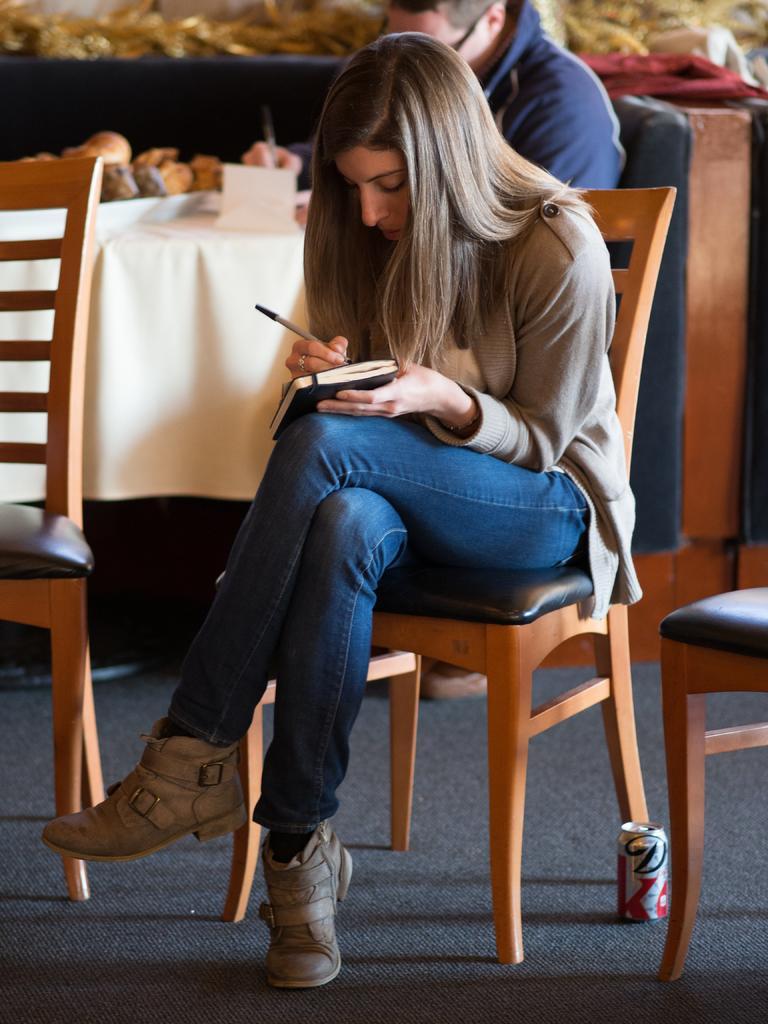Can you describe this image briefly? This picture shows a woman sitting on a table writing something, behind her there are two chairs, in the background we can see a person writing something in his notes and also we can see a table with cloth. Behind a woman there is a drink. 